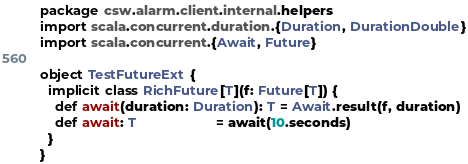<code> <loc_0><loc_0><loc_500><loc_500><_Scala_>package csw.alarm.client.internal.helpers
import scala.concurrent.duration.{Duration, DurationDouble}
import scala.concurrent.{Await, Future}

object TestFutureExt {
  implicit class RichFuture[T](f: Future[T]) {
    def await(duration: Duration): T = Await.result(f, duration)
    def await: T                     = await(10.seconds)
  }
}
</code> 